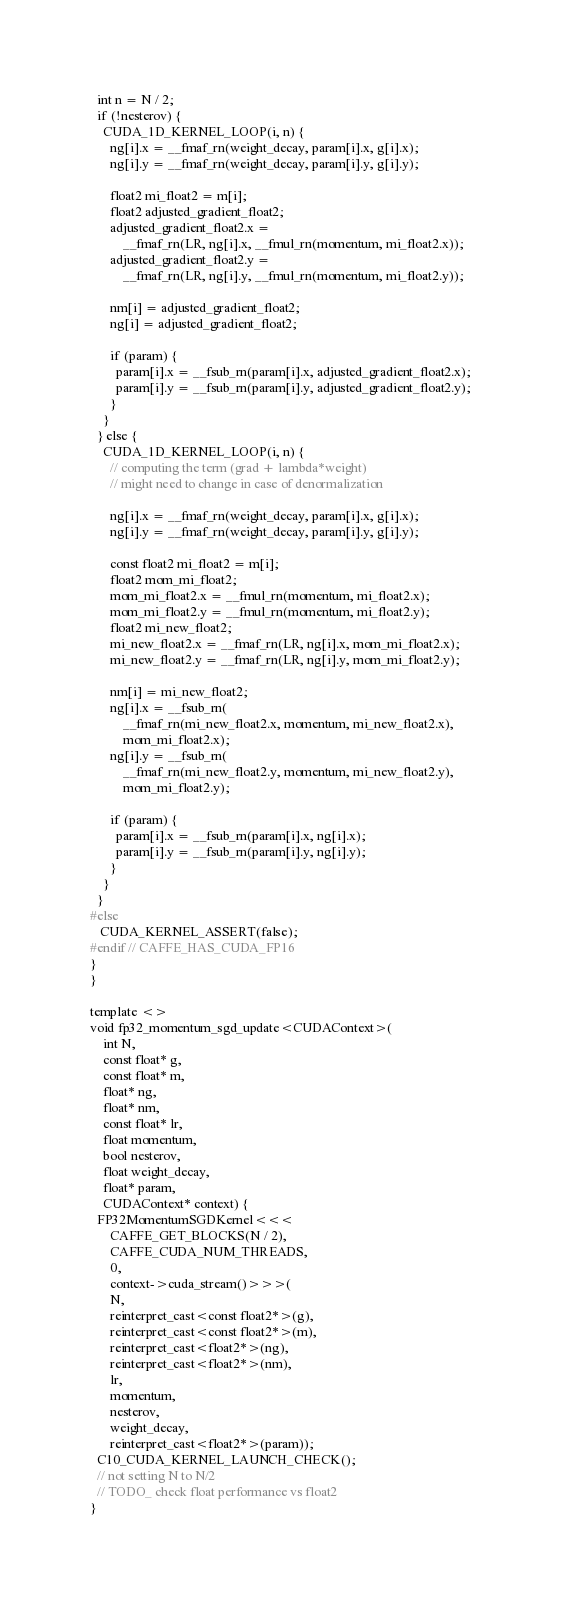Convert code to text. <code><loc_0><loc_0><loc_500><loc_500><_Cuda_>  int n = N / 2;
  if (!nesterov) {
    CUDA_1D_KERNEL_LOOP(i, n) {
      ng[i].x = __fmaf_rn(weight_decay, param[i].x, g[i].x);
      ng[i].y = __fmaf_rn(weight_decay, param[i].y, g[i].y);

      float2 mi_float2 = m[i];
      float2 adjusted_gradient_float2;
      adjusted_gradient_float2.x =
          __fmaf_rn(LR, ng[i].x, __fmul_rn(momentum, mi_float2.x));
      adjusted_gradient_float2.y =
          __fmaf_rn(LR, ng[i].y, __fmul_rn(momentum, mi_float2.y));

      nm[i] = adjusted_gradient_float2;
      ng[i] = adjusted_gradient_float2;

      if (param) {
        param[i].x = __fsub_rn(param[i].x, adjusted_gradient_float2.x);
        param[i].y = __fsub_rn(param[i].y, adjusted_gradient_float2.y);
      }
    }
  } else {
    CUDA_1D_KERNEL_LOOP(i, n) {
      // computing the term (grad + lambda*weight)
      // might need to change in case of denormalization

      ng[i].x = __fmaf_rn(weight_decay, param[i].x, g[i].x);
      ng[i].y = __fmaf_rn(weight_decay, param[i].y, g[i].y);

      const float2 mi_float2 = m[i];
      float2 mom_mi_float2;
      mom_mi_float2.x = __fmul_rn(momentum, mi_float2.x);
      mom_mi_float2.y = __fmul_rn(momentum, mi_float2.y);
      float2 mi_new_float2;
      mi_new_float2.x = __fmaf_rn(LR, ng[i].x, mom_mi_float2.x);
      mi_new_float2.y = __fmaf_rn(LR, ng[i].y, mom_mi_float2.y);

      nm[i] = mi_new_float2;
      ng[i].x = __fsub_rn(
          __fmaf_rn(mi_new_float2.x, momentum, mi_new_float2.x),
          mom_mi_float2.x);
      ng[i].y = __fsub_rn(
          __fmaf_rn(mi_new_float2.y, momentum, mi_new_float2.y),
          mom_mi_float2.y);

      if (param) {
        param[i].x = __fsub_rn(param[i].x, ng[i].x);
        param[i].y = __fsub_rn(param[i].y, ng[i].y);
      }
    }
  }
#else
   CUDA_KERNEL_ASSERT(false);
#endif // CAFFE_HAS_CUDA_FP16
}
}

template <>
void fp32_momentum_sgd_update<CUDAContext>(
    int N,
    const float* g,
    const float* m,
    float* ng,
    float* nm,
    const float* lr,
    float momentum,
    bool nesterov,
    float weight_decay,
    float* param,
    CUDAContext* context) {
  FP32MomentumSGDKernel<<<
      CAFFE_GET_BLOCKS(N / 2),
      CAFFE_CUDA_NUM_THREADS,
      0,
      context->cuda_stream()>>>(
      N,
      reinterpret_cast<const float2*>(g),
      reinterpret_cast<const float2*>(m),
      reinterpret_cast<float2*>(ng),
      reinterpret_cast<float2*>(nm),
      lr,
      momentum,
      nesterov,
      weight_decay,
      reinterpret_cast<float2*>(param));
  C10_CUDA_KERNEL_LAUNCH_CHECK();
  // not setting N to N/2
  // TODO_ check float performance vs float2
}
</code> 